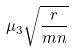Convert formula to latex. <formula><loc_0><loc_0><loc_500><loc_500>\mu _ { 3 } \sqrt { \frac { r } { m n } }</formula> 